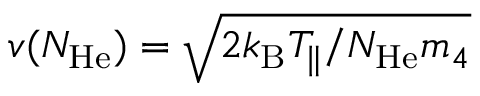Convert formula to latex. <formula><loc_0><loc_0><loc_500><loc_500>v ( N _ { H e } ) = \sqrt { 2 k _ { B } T _ { \| } / N _ { H e } m _ { 4 } }</formula> 